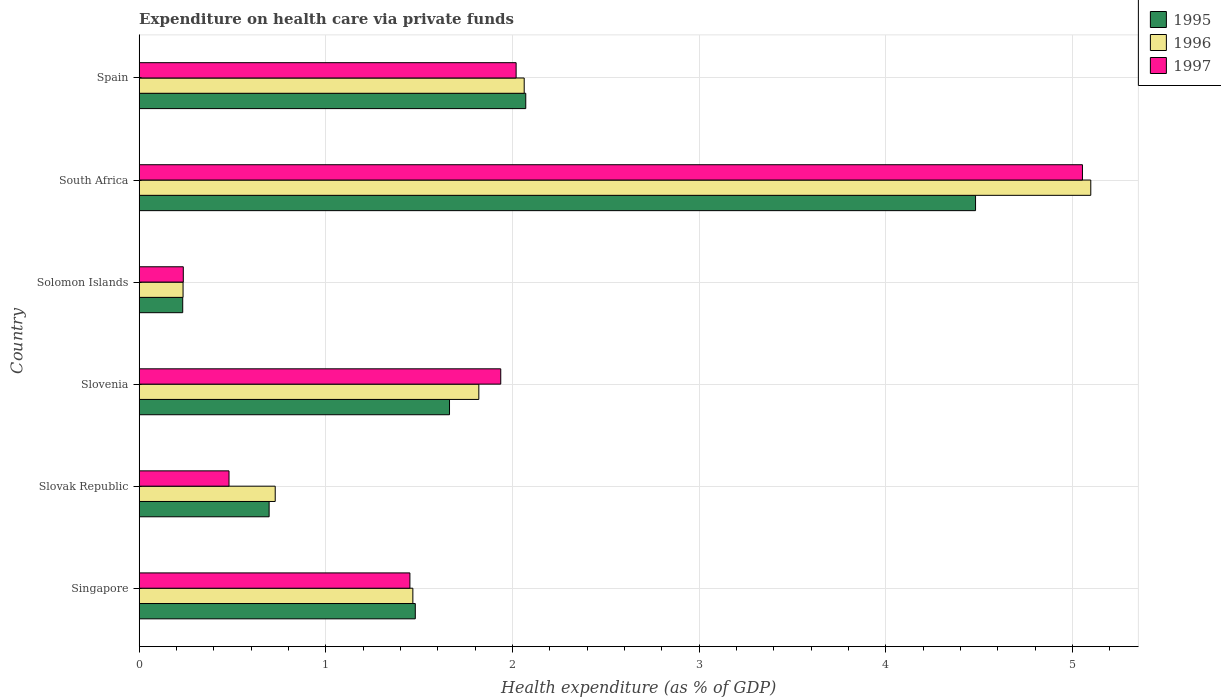How many bars are there on the 2nd tick from the bottom?
Offer a terse response. 3. What is the label of the 1st group of bars from the top?
Your answer should be compact. Spain. In how many cases, is the number of bars for a given country not equal to the number of legend labels?
Your answer should be compact. 0. What is the expenditure made on health care in 1997 in Slovenia?
Provide a short and direct response. 1.94. Across all countries, what is the maximum expenditure made on health care in 1995?
Provide a succinct answer. 4.48. Across all countries, what is the minimum expenditure made on health care in 1995?
Your answer should be very brief. 0.23. In which country was the expenditure made on health care in 1996 maximum?
Your response must be concise. South Africa. In which country was the expenditure made on health care in 1996 minimum?
Ensure brevity in your answer.  Solomon Islands. What is the total expenditure made on health care in 1995 in the graph?
Your answer should be very brief. 10.62. What is the difference between the expenditure made on health care in 1996 in South Africa and that in Spain?
Provide a succinct answer. 3.04. What is the difference between the expenditure made on health care in 1995 in Spain and the expenditure made on health care in 1997 in Solomon Islands?
Make the answer very short. 1.83. What is the average expenditure made on health care in 1995 per country?
Your answer should be very brief. 1.77. What is the difference between the expenditure made on health care in 1995 and expenditure made on health care in 1997 in Slovenia?
Keep it short and to the point. -0.27. What is the ratio of the expenditure made on health care in 1997 in Singapore to that in Solomon Islands?
Keep it short and to the point. 6.13. What is the difference between the highest and the second highest expenditure made on health care in 1997?
Make the answer very short. 3.03. What is the difference between the highest and the lowest expenditure made on health care in 1995?
Provide a short and direct response. 4.25. Is the sum of the expenditure made on health care in 1995 in Solomon Islands and South Africa greater than the maximum expenditure made on health care in 1996 across all countries?
Your answer should be compact. No. What does the 2nd bar from the bottom in Slovenia represents?
Your response must be concise. 1996. Is it the case that in every country, the sum of the expenditure made on health care in 1997 and expenditure made on health care in 1995 is greater than the expenditure made on health care in 1996?
Your response must be concise. Yes. What is the difference between two consecutive major ticks on the X-axis?
Offer a very short reply. 1. Does the graph contain any zero values?
Your answer should be very brief. No. Does the graph contain grids?
Offer a very short reply. Yes. Where does the legend appear in the graph?
Your answer should be compact. Top right. How are the legend labels stacked?
Your response must be concise. Vertical. What is the title of the graph?
Make the answer very short. Expenditure on health care via private funds. What is the label or title of the X-axis?
Offer a terse response. Health expenditure (as % of GDP). What is the Health expenditure (as % of GDP) of 1995 in Singapore?
Ensure brevity in your answer.  1.48. What is the Health expenditure (as % of GDP) of 1996 in Singapore?
Ensure brevity in your answer.  1.47. What is the Health expenditure (as % of GDP) of 1997 in Singapore?
Provide a succinct answer. 1.45. What is the Health expenditure (as % of GDP) in 1995 in Slovak Republic?
Your response must be concise. 0.7. What is the Health expenditure (as % of GDP) in 1996 in Slovak Republic?
Your answer should be compact. 0.73. What is the Health expenditure (as % of GDP) of 1997 in Slovak Republic?
Provide a short and direct response. 0.48. What is the Health expenditure (as % of GDP) of 1995 in Slovenia?
Offer a terse response. 1.66. What is the Health expenditure (as % of GDP) of 1996 in Slovenia?
Offer a terse response. 1.82. What is the Health expenditure (as % of GDP) in 1997 in Slovenia?
Give a very brief answer. 1.94. What is the Health expenditure (as % of GDP) of 1995 in Solomon Islands?
Offer a terse response. 0.23. What is the Health expenditure (as % of GDP) of 1996 in Solomon Islands?
Keep it short and to the point. 0.24. What is the Health expenditure (as % of GDP) of 1997 in Solomon Islands?
Your answer should be very brief. 0.24. What is the Health expenditure (as % of GDP) of 1995 in South Africa?
Give a very brief answer. 4.48. What is the Health expenditure (as % of GDP) of 1996 in South Africa?
Offer a very short reply. 5.1. What is the Health expenditure (as % of GDP) of 1997 in South Africa?
Your response must be concise. 5.05. What is the Health expenditure (as % of GDP) of 1995 in Spain?
Offer a very short reply. 2.07. What is the Health expenditure (as % of GDP) in 1996 in Spain?
Ensure brevity in your answer.  2.06. What is the Health expenditure (as % of GDP) of 1997 in Spain?
Offer a terse response. 2.02. Across all countries, what is the maximum Health expenditure (as % of GDP) in 1995?
Ensure brevity in your answer.  4.48. Across all countries, what is the maximum Health expenditure (as % of GDP) in 1996?
Offer a terse response. 5.1. Across all countries, what is the maximum Health expenditure (as % of GDP) of 1997?
Your answer should be compact. 5.05. Across all countries, what is the minimum Health expenditure (as % of GDP) of 1995?
Your response must be concise. 0.23. Across all countries, what is the minimum Health expenditure (as % of GDP) in 1996?
Keep it short and to the point. 0.24. Across all countries, what is the minimum Health expenditure (as % of GDP) in 1997?
Your answer should be compact. 0.24. What is the total Health expenditure (as % of GDP) in 1995 in the graph?
Your response must be concise. 10.62. What is the total Health expenditure (as % of GDP) of 1996 in the graph?
Your answer should be compact. 11.41. What is the total Health expenditure (as % of GDP) in 1997 in the graph?
Provide a short and direct response. 11.18. What is the difference between the Health expenditure (as % of GDP) in 1995 in Singapore and that in Slovak Republic?
Your response must be concise. 0.78. What is the difference between the Health expenditure (as % of GDP) in 1996 in Singapore and that in Slovak Republic?
Your answer should be compact. 0.74. What is the difference between the Health expenditure (as % of GDP) in 1997 in Singapore and that in Slovak Republic?
Provide a short and direct response. 0.97. What is the difference between the Health expenditure (as % of GDP) in 1995 in Singapore and that in Slovenia?
Your answer should be compact. -0.18. What is the difference between the Health expenditure (as % of GDP) of 1996 in Singapore and that in Slovenia?
Give a very brief answer. -0.35. What is the difference between the Health expenditure (as % of GDP) in 1997 in Singapore and that in Slovenia?
Keep it short and to the point. -0.49. What is the difference between the Health expenditure (as % of GDP) in 1995 in Singapore and that in Solomon Islands?
Your answer should be very brief. 1.25. What is the difference between the Health expenditure (as % of GDP) in 1996 in Singapore and that in Solomon Islands?
Keep it short and to the point. 1.23. What is the difference between the Health expenditure (as % of GDP) of 1997 in Singapore and that in Solomon Islands?
Ensure brevity in your answer.  1.21. What is the difference between the Health expenditure (as % of GDP) of 1995 in Singapore and that in South Africa?
Ensure brevity in your answer.  -3. What is the difference between the Health expenditure (as % of GDP) of 1996 in Singapore and that in South Africa?
Ensure brevity in your answer.  -3.63. What is the difference between the Health expenditure (as % of GDP) in 1997 in Singapore and that in South Africa?
Make the answer very short. -3.6. What is the difference between the Health expenditure (as % of GDP) of 1995 in Singapore and that in Spain?
Provide a succinct answer. -0.59. What is the difference between the Health expenditure (as % of GDP) in 1996 in Singapore and that in Spain?
Your answer should be compact. -0.6. What is the difference between the Health expenditure (as % of GDP) of 1997 in Singapore and that in Spain?
Offer a terse response. -0.57. What is the difference between the Health expenditure (as % of GDP) in 1995 in Slovak Republic and that in Slovenia?
Provide a succinct answer. -0.97. What is the difference between the Health expenditure (as % of GDP) of 1996 in Slovak Republic and that in Slovenia?
Offer a terse response. -1.09. What is the difference between the Health expenditure (as % of GDP) in 1997 in Slovak Republic and that in Slovenia?
Ensure brevity in your answer.  -1.46. What is the difference between the Health expenditure (as % of GDP) in 1995 in Slovak Republic and that in Solomon Islands?
Make the answer very short. 0.46. What is the difference between the Health expenditure (as % of GDP) of 1996 in Slovak Republic and that in Solomon Islands?
Your answer should be compact. 0.49. What is the difference between the Health expenditure (as % of GDP) in 1997 in Slovak Republic and that in Solomon Islands?
Offer a terse response. 0.24. What is the difference between the Health expenditure (as % of GDP) in 1995 in Slovak Republic and that in South Africa?
Your answer should be compact. -3.78. What is the difference between the Health expenditure (as % of GDP) in 1996 in Slovak Republic and that in South Africa?
Your answer should be very brief. -4.37. What is the difference between the Health expenditure (as % of GDP) of 1997 in Slovak Republic and that in South Africa?
Make the answer very short. -4.57. What is the difference between the Health expenditure (as % of GDP) in 1995 in Slovak Republic and that in Spain?
Your response must be concise. -1.37. What is the difference between the Health expenditure (as % of GDP) in 1996 in Slovak Republic and that in Spain?
Offer a terse response. -1.33. What is the difference between the Health expenditure (as % of GDP) of 1997 in Slovak Republic and that in Spain?
Provide a short and direct response. -1.54. What is the difference between the Health expenditure (as % of GDP) in 1995 in Slovenia and that in Solomon Islands?
Keep it short and to the point. 1.43. What is the difference between the Health expenditure (as % of GDP) in 1996 in Slovenia and that in Solomon Islands?
Your response must be concise. 1.58. What is the difference between the Health expenditure (as % of GDP) in 1997 in Slovenia and that in Solomon Islands?
Offer a very short reply. 1.7. What is the difference between the Health expenditure (as % of GDP) of 1995 in Slovenia and that in South Africa?
Keep it short and to the point. -2.82. What is the difference between the Health expenditure (as % of GDP) in 1996 in Slovenia and that in South Africa?
Offer a terse response. -3.28. What is the difference between the Health expenditure (as % of GDP) of 1997 in Slovenia and that in South Africa?
Keep it short and to the point. -3.12. What is the difference between the Health expenditure (as % of GDP) in 1995 in Slovenia and that in Spain?
Offer a terse response. -0.41. What is the difference between the Health expenditure (as % of GDP) in 1996 in Slovenia and that in Spain?
Provide a short and direct response. -0.24. What is the difference between the Health expenditure (as % of GDP) of 1997 in Slovenia and that in Spain?
Your answer should be very brief. -0.08. What is the difference between the Health expenditure (as % of GDP) in 1995 in Solomon Islands and that in South Africa?
Offer a terse response. -4.25. What is the difference between the Health expenditure (as % of GDP) in 1996 in Solomon Islands and that in South Africa?
Give a very brief answer. -4.86. What is the difference between the Health expenditure (as % of GDP) in 1997 in Solomon Islands and that in South Africa?
Offer a terse response. -4.82. What is the difference between the Health expenditure (as % of GDP) in 1995 in Solomon Islands and that in Spain?
Your answer should be compact. -1.84. What is the difference between the Health expenditure (as % of GDP) of 1996 in Solomon Islands and that in Spain?
Your answer should be compact. -1.83. What is the difference between the Health expenditure (as % of GDP) of 1997 in Solomon Islands and that in Spain?
Ensure brevity in your answer.  -1.78. What is the difference between the Health expenditure (as % of GDP) in 1995 in South Africa and that in Spain?
Make the answer very short. 2.41. What is the difference between the Health expenditure (as % of GDP) of 1996 in South Africa and that in Spain?
Your answer should be compact. 3.04. What is the difference between the Health expenditure (as % of GDP) in 1997 in South Africa and that in Spain?
Give a very brief answer. 3.03. What is the difference between the Health expenditure (as % of GDP) of 1995 in Singapore and the Health expenditure (as % of GDP) of 1996 in Slovak Republic?
Offer a very short reply. 0.75. What is the difference between the Health expenditure (as % of GDP) of 1995 in Singapore and the Health expenditure (as % of GDP) of 1997 in Slovak Republic?
Make the answer very short. 1. What is the difference between the Health expenditure (as % of GDP) in 1996 in Singapore and the Health expenditure (as % of GDP) in 1997 in Slovak Republic?
Your answer should be very brief. 0.98. What is the difference between the Health expenditure (as % of GDP) of 1995 in Singapore and the Health expenditure (as % of GDP) of 1996 in Slovenia?
Give a very brief answer. -0.34. What is the difference between the Health expenditure (as % of GDP) in 1995 in Singapore and the Health expenditure (as % of GDP) in 1997 in Slovenia?
Keep it short and to the point. -0.46. What is the difference between the Health expenditure (as % of GDP) of 1996 in Singapore and the Health expenditure (as % of GDP) of 1997 in Slovenia?
Give a very brief answer. -0.47. What is the difference between the Health expenditure (as % of GDP) of 1995 in Singapore and the Health expenditure (as % of GDP) of 1996 in Solomon Islands?
Your answer should be compact. 1.24. What is the difference between the Health expenditure (as % of GDP) in 1995 in Singapore and the Health expenditure (as % of GDP) in 1997 in Solomon Islands?
Provide a succinct answer. 1.24. What is the difference between the Health expenditure (as % of GDP) in 1996 in Singapore and the Health expenditure (as % of GDP) in 1997 in Solomon Islands?
Provide a short and direct response. 1.23. What is the difference between the Health expenditure (as % of GDP) of 1995 in Singapore and the Health expenditure (as % of GDP) of 1996 in South Africa?
Provide a short and direct response. -3.62. What is the difference between the Health expenditure (as % of GDP) in 1995 in Singapore and the Health expenditure (as % of GDP) in 1997 in South Africa?
Your response must be concise. -3.57. What is the difference between the Health expenditure (as % of GDP) of 1996 in Singapore and the Health expenditure (as % of GDP) of 1997 in South Africa?
Make the answer very short. -3.59. What is the difference between the Health expenditure (as % of GDP) in 1995 in Singapore and the Health expenditure (as % of GDP) in 1996 in Spain?
Provide a succinct answer. -0.58. What is the difference between the Health expenditure (as % of GDP) in 1995 in Singapore and the Health expenditure (as % of GDP) in 1997 in Spain?
Your answer should be compact. -0.54. What is the difference between the Health expenditure (as % of GDP) of 1996 in Singapore and the Health expenditure (as % of GDP) of 1997 in Spain?
Keep it short and to the point. -0.55. What is the difference between the Health expenditure (as % of GDP) of 1995 in Slovak Republic and the Health expenditure (as % of GDP) of 1996 in Slovenia?
Keep it short and to the point. -1.12. What is the difference between the Health expenditure (as % of GDP) in 1995 in Slovak Republic and the Health expenditure (as % of GDP) in 1997 in Slovenia?
Offer a terse response. -1.24. What is the difference between the Health expenditure (as % of GDP) of 1996 in Slovak Republic and the Health expenditure (as % of GDP) of 1997 in Slovenia?
Offer a very short reply. -1.21. What is the difference between the Health expenditure (as % of GDP) of 1995 in Slovak Republic and the Health expenditure (as % of GDP) of 1996 in Solomon Islands?
Make the answer very short. 0.46. What is the difference between the Health expenditure (as % of GDP) in 1995 in Slovak Republic and the Health expenditure (as % of GDP) in 1997 in Solomon Islands?
Make the answer very short. 0.46. What is the difference between the Health expenditure (as % of GDP) in 1996 in Slovak Republic and the Health expenditure (as % of GDP) in 1997 in Solomon Islands?
Make the answer very short. 0.49. What is the difference between the Health expenditure (as % of GDP) of 1995 in Slovak Republic and the Health expenditure (as % of GDP) of 1996 in South Africa?
Make the answer very short. -4.4. What is the difference between the Health expenditure (as % of GDP) in 1995 in Slovak Republic and the Health expenditure (as % of GDP) in 1997 in South Africa?
Your response must be concise. -4.36. What is the difference between the Health expenditure (as % of GDP) of 1996 in Slovak Republic and the Health expenditure (as % of GDP) of 1997 in South Africa?
Provide a succinct answer. -4.32. What is the difference between the Health expenditure (as % of GDP) in 1995 in Slovak Republic and the Health expenditure (as % of GDP) in 1996 in Spain?
Give a very brief answer. -1.37. What is the difference between the Health expenditure (as % of GDP) in 1995 in Slovak Republic and the Health expenditure (as % of GDP) in 1997 in Spain?
Your answer should be very brief. -1.32. What is the difference between the Health expenditure (as % of GDP) in 1996 in Slovak Republic and the Health expenditure (as % of GDP) in 1997 in Spain?
Provide a succinct answer. -1.29. What is the difference between the Health expenditure (as % of GDP) of 1995 in Slovenia and the Health expenditure (as % of GDP) of 1996 in Solomon Islands?
Give a very brief answer. 1.43. What is the difference between the Health expenditure (as % of GDP) of 1995 in Slovenia and the Health expenditure (as % of GDP) of 1997 in Solomon Islands?
Provide a succinct answer. 1.43. What is the difference between the Health expenditure (as % of GDP) in 1996 in Slovenia and the Health expenditure (as % of GDP) in 1997 in Solomon Islands?
Give a very brief answer. 1.58. What is the difference between the Health expenditure (as % of GDP) in 1995 in Slovenia and the Health expenditure (as % of GDP) in 1996 in South Africa?
Make the answer very short. -3.44. What is the difference between the Health expenditure (as % of GDP) in 1995 in Slovenia and the Health expenditure (as % of GDP) in 1997 in South Africa?
Ensure brevity in your answer.  -3.39. What is the difference between the Health expenditure (as % of GDP) of 1996 in Slovenia and the Health expenditure (as % of GDP) of 1997 in South Africa?
Offer a terse response. -3.23. What is the difference between the Health expenditure (as % of GDP) in 1995 in Slovenia and the Health expenditure (as % of GDP) in 1996 in Spain?
Offer a very short reply. -0.4. What is the difference between the Health expenditure (as % of GDP) of 1995 in Slovenia and the Health expenditure (as % of GDP) of 1997 in Spain?
Make the answer very short. -0.36. What is the difference between the Health expenditure (as % of GDP) of 1996 in Slovenia and the Health expenditure (as % of GDP) of 1997 in Spain?
Ensure brevity in your answer.  -0.2. What is the difference between the Health expenditure (as % of GDP) of 1995 in Solomon Islands and the Health expenditure (as % of GDP) of 1996 in South Africa?
Make the answer very short. -4.86. What is the difference between the Health expenditure (as % of GDP) of 1995 in Solomon Islands and the Health expenditure (as % of GDP) of 1997 in South Africa?
Your response must be concise. -4.82. What is the difference between the Health expenditure (as % of GDP) in 1996 in Solomon Islands and the Health expenditure (as % of GDP) in 1997 in South Africa?
Keep it short and to the point. -4.82. What is the difference between the Health expenditure (as % of GDP) in 1995 in Solomon Islands and the Health expenditure (as % of GDP) in 1996 in Spain?
Your answer should be very brief. -1.83. What is the difference between the Health expenditure (as % of GDP) in 1995 in Solomon Islands and the Health expenditure (as % of GDP) in 1997 in Spain?
Give a very brief answer. -1.79. What is the difference between the Health expenditure (as % of GDP) of 1996 in Solomon Islands and the Health expenditure (as % of GDP) of 1997 in Spain?
Your response must be concise. -1.78. What is the difference between the Health expenditure (as % of GDP) in 1995 in South Africa and the Health expenditure (as % of GDP) in 1996 in Spain?
Your response must be concise. 2.42. What is the difference between the Health expenditure (as % of GDP) in 1995 in South Africa and the Health expenditure (as % of GDP) in 1997 in Spain?
Your answer should be very brief. 2.46. What is the difference between the Health expenditure (as % of GDP) of 1996 in South Africa and the Health expenditure (as % of GDP) of 1997 in Spain?
Provide a succinct answer. 3.08. What is the average Health expenditure (as % of GDP) in 1995 per country?
Provide a short and direct response. 1.77. What is the average Health expenditure (as % of GDP) of 1996 per country?
Your answer should be compact. 1.9. What is the average Health expenditure (as % of GDP) of 1997 per country?
Give a very brief answer. 1.86. What is the difference between the Health expenditure (as % of GDP) in 1995 and Health expenditure (as % of GDP) in 1996 in Singapore?
Your answer should be very brief. 0.01. What is the difference between the Health expenditure (as % of GDP) in 1995 and Health expenditure (as % of GDP) in 1997 in Singapore?
Your answer should be very brief. 0.03. What is the difference between the Health expenditure (as % of GDP) of 1996 and Health expenditure (as % of GDP) of 1997 in Singapore?
Offer a terse response. 0.02. What is the difference between the Health expenditure (as % of GDP) in 1995 and Health expenditure (as % of GDP) in 1996 in Slovak Republic?
Provide a short and direct response. -0.03. What is the difference between the Health expenditure (as % of GDP) in 1995 and Health expenditure (as % of GDP) in 1997 in Slovak Republic?
Your answer should be compact. 0.21. What is the difference between the Health expenditure (as % of GDP) of 1996 and Health expenditure (as % of GDP) of 1997 in Slovak Republic?
Ensure brevity in your answer.  0.25. What is the difference between the Health expenditure (as % of GDP) in 1995 and Health expenditure (as % of GDP) in 1996 in Slovenia?
Provide a succinct answer. -0.16. What is the difference between the Health expenditure (as % of GDP) of 1995 and Health expenditure (as % of GDP) of 1997 in Slovenia?
Provide a short and direct response. -0.27. What is the difference between the Health expenditure (as % of GDP) in 1996 and Health expenditure (as % of GDP) in 1997 in Slovenia?
Offer a very short reply. -0.12. What is the difference between the Health expenditure (as % of GDP) in 1995 and Health expenditure (as % of GDP) in 1996 in Solomon Islands?
Offer a very short reply. -0. What is the difference between the Health expenditure (as % of GDP) of 1995 and Health expenditure (as % of GDP) of 1997 in Solomon Islands?
Keep it short and to the point. -0. What is the difference between the Health expenditure (as % of GDP) of 1996 and Health expenditure (as % of GDP) of 1997 in Solomon Islands?
Offer a very short reply. -0. What is the difference between the Health expenditure (as % of GDP) of 1995 and Health expenditure (as % of GDP) of 1996 in South Africa?
Ensure brevity in your answer.  -0.62. What is the difference between the Health expenditure (as % of GDP) of 1995 and Health expenditure (as % of GDP) of 1997 in South Africa?
Your response must be concise. -0.57. What is the difference between the Health expenditure (as % of GDP) of 1996 and Health expenditure (as % of GDP) of 1997 in South Africa?
Your answer should be very brief. 0.04. What is the difference between the Health expenditure (as % of GDP) in 1995 and Health expenditure (as % of GDP) in 1996 in Spain?
Your response must be concise. 0.01. What is the difference between the Health expenditure (as % of GDP) in 1995 and Health expenditure (as % of GDP) in 1997 in Spain?
Your response must be concise. 0.05. What is the difference between the Health expenditure (as % of GDP) of 1996 and Health expenditure (as % of GDP) of 1997 in Spain?
Your response must be concise. 0.04. What is the ratio of the Health expenditure (as % of GDP) in 1995 in Singapore to that in Slovak Republic?
Give a very brief answer. 2.12. What is the ratio of the Health expenditure (as % of GDP) of 1996 in Singapore to that in Slovak Republic?
Keep it short and to the point. 2.01. What is the ratio of the Health expenditure (as % of GDP) of 1997 in Singapore to that in Slovak Republic?
Offer a very short reply. 3.01. What is the ratio of the Health expenditure (as % of GDP) of 1995 in Singapore to that in Slovenia?
Provide a succinct answer. 0.89. What is the ratio of the Health expenditure (as % of GDP) in 1996 in Singapore to that in Slovenia?
Provide a short and direct response. 0.81. What is the ratio of the Health expenditure (as % of GDP) in 1997 in Singapore to that in Slovenia?
Your response must be concise. 0.75. What is the ratio of the Health expenditure (as % of GDP) of 1995 in Singapore to that in Solomon Islands?
Your answer should be very brief. 6.34. What is the ratio of the Health expenditure (as % of GDP) of 1996 in Singapore to that in Solomon Islands?
Provide a succinct answer. 6.24. What is the ratio of the Health expenditure (as % of GDP) of 1997 in Singapore to that in Solomon Islands?
Give a very brief answer. 6.13. What is the ratio of the Health expenditure (as % of GDP) of 1995 in Singapore to that in South Africa?
Make the answer very short. 0.33. What is the ratio of the Health expenditure (as % of GDP) in 1996 in Singapore to that in South Africa?
Your response must be concise. 0.29. What is the ratio of the Health expenditure (as % of GDP) in 1997 in Singapore to that in South Africa?
Give a very brief answer. 0.29. What is the ratio of the Health expenditure (as % of GDP) in 1995 in Singapore to that in Spain?
Provide a succinct answer. 0.71. What is the ratio of the Health expenditure (as % of GDP) of 1996 in Singapore to that in Spain?
Offer a very short reply. 0.71. What is the ratio of the Health expenditure (as % of GDP) of 1997 in Singapore to that in Spain?
Keep it short and to the point. 0.72. What is the ratio of the Health expenditure (as % of GDP) of 1995 in Slovak Republic to that in Slovenia?
Keep it short and to the point. 0.42. What is the ratio of the Health expenditure (as % of GDP) of 1996 in Slovak Republic to that in Slovenia?
Offer a very short reply. 0.4. What is the ratio of the Health expenditure (as % of GDP) in 1997 in Slovak Republic to that in Slovenia?
Provide a succinct answer. 0.25. What is the ratio of the Health expenditure (as % of GDP) of 1995 in Slovak Republic to that in Solomon Islands?
Provide a succinct answer. 2.98. What is the ratio of the Health expenditure (as % of GDP) in 1996 in Slovak Republic to that in Solomon Islands?
Your answer should be compact. 3.1. What is the ratio of the Health expenditure (as % of GDP) of 1997 in Slovak Republic to that in Solomon Islands?
Your answer should be compact. 2.04. What is the ratio of the Health expenditure (as % of GDP) of 1995 in Slovak Republic to that in South Africa?
Offer a very short reply. 0.16. What is the ratio of the Health expenditure (as % of GDP) in 1996 in Slovak Republic to that in South Africa?
Your response must be concise. 0.14. What is the ratio of the Health expenditure (as % of GDP) of 1997 in Slovak Republic to that in South Africa?
Offer a terse response. 0.1. What is the ratio of the Health expenditure (as % of GDP) in 1995 in Slovak Republic to that in Spain?
Provide a short and direct response. 0.34. What is the ratio of the Health expenditure (as % of GDP) of 1996 in Slovak Republic to that in Spain?
Your answer should be very brief. 0.35. What is the ratio of the Health expenditure (as % of GDP) in 1997 in Slovak Republic to that in Spain?
Offer a very short reply. 0.24. What is the ratio of the Health expenditure (as % of GDP) of 1995 in Slovenia to that in Solomon Islands?
Ensure brevity in your answer.  7.12. What is the ratio of the Health expenditure (as % of GDP) in 1996 in Slovenia to that in Solomon Islands?
Offer a very short reply. 7.74. What is the ratio of the Health expenditure (as % of GDP) in 1997 in Slovenia to that in Solomon Islands?
Your answer should be compact. 8.19. What is the ratio of the Health expenditure (as % of GDP) in 1995 in Slovenia to that in South Africa?
Keep it short and to the point. 0.37. What is the ratio of the Health expenditure (as % of GDP) in 1996 in Slovenia to that in South Africa?
Provide a succinct answer. 0.36. What is the ratio of the Health expenditure (as % of GDP) of 1997 in Slovenia to that in South Africa?
Provide a short and direct response. 0.38. What is the ratio of the Health expenditure (as % of GDP) in 1995 in Slovenia to that in Spain?
Give a very brief answer. 0.8. What is the ratio of the Health expenditure (as % of GDP) of 1996 in Slovenia to that in Spain?
Your response must be concise. 0.88. What is the ratio of the Health expenditure (as % of GDP) in 1997 in Slovenia to that in Spain?
Provide a short and direct response. 0.96. What is the ratio of the Health expenditure (as % of GDP) of 1995 in Solomon Islands to that in South Africa?
Your answer should be very brief. 0.05. What is the ratio of the Health expenditure (as % of GDP) of 1996 in Solomon Islands to that in South Africa?
Offer a very short reply. 0.05. What is the ratio of the Health expenditure (as % of GDP) of 1997 in Solomon Islands to that in South Africa?
Offer a very short reply. 0.05. What is the ratio of the Health expenditure (as % of GDP) in 1995 in Solomon Islands to that in Spain?
Keep it short and to the point. 0.11. What is the ratio of the Health expenditure (as % of GDP) of 1996 in Solomon Islands to that in Spain?
Keep it short and to the point. 0.11. What is the ratio of the Health expenditure (as % of GDP) of 1997 in Solomon Islands to that in Spain?
Ensure brevity in your answer.  0.12. What is the ratio of the Health expenditure (as % of GDP) in 1995 in South Africa to that in Spain?
Keep it short and to the point. 2.16. What is the ratio of the Health expenditure (as % of GDP) in 1996 in South Africa to that in Spain?
Your answer should be compact. 2.47. What is the ratio of the Health expenditure (as % of GDP) of 1997 in South Africa to that in Spain?
Provide a succinct answer. 2.5. What is the difference between the highest and the second highest Health expenditure (as % of GDP) of 1995?
Give a very brief answer. 2.41. What is the difference between the highest and the second highest Health expenditure (as % of GDP) in 1996?
Give a very brief answer. 3.04. What is the difference between the highest and the second highest Health expenditure (as % of GDP) of 1997?
Keep it short and to the point. 3.03. What is the difference between the highest and the lowest Health expenditure (as % of GDP) in 1995?
Give a very brief answer. 4.25. What is the difference between the highest and the lowest Health expenditure (as % of GDP) in 1996?
Your response must be concise. 4.86. What is the difference between the highest and the lowest Health expenditure (as % of GDP) of 1997?
Your answer should be compact. 4.82. 